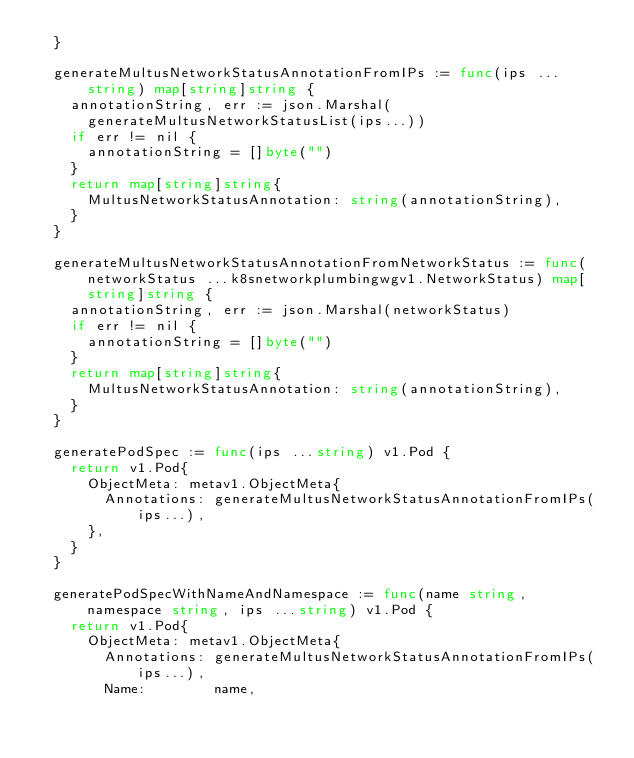Convert code to text. <code><loc_0><loc_0><loc_500><loc_500><_Go_>	}

	generateMultusNetworkStatusAnnotationFromIPs := func(ips ...string) map[string]string {
		annotationString, err := json.Marshal(
			generateMultusNetworkStatusList(ips...))
		if err != nil {
			annotationString = []byte("")
		}
		return map[string]string{
			MultusNetworkStatusAnnotation: string(annotationString),
		}
	}

	generateMultusNetworkStatusAnnotationFromNetworkStatus := func(networkStatus ...k8snetworkplumbingwgv1.NetworkStatus) map[string]string {
		annotationString, err := json.Marshal(networkStatus)
		if err != nil {
			annotationString = []byte("")
		}
		return map[string]string{
			MultusNetworkStatusAnnotation: string(annotationString),
		}
	}

	generatePodSpec := func(ips ...string) v1.Pod {
		return v1.Pod{
			ObjectMeta: metav1.ObjectMeta{
				Annotations: generateMultusNetworkStatusAnnotationFromIPs(ips...),
			},
		}
	}

	generatePodSpecWithNameAndNamespace := func(name string, namespace string, ips ...string) v1.Pod {
		return v1.Pod{
			ObjectMeta: metav1.ObjectMeta{
				Annotations: generateMultusNetworkStatusAnnotationFromIPs(ips...),
				Name:        name,</code> 